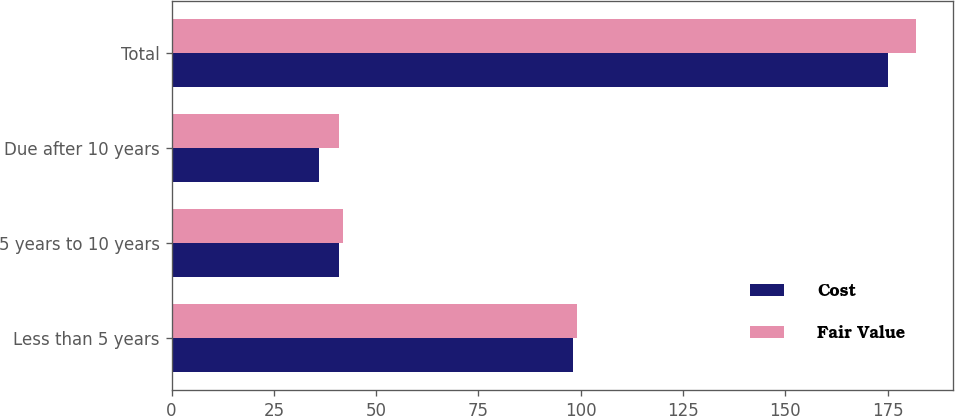Convert chart to OTSL. <chart><loc_0><loc_0><loc_500><loc_500><stacked_bar_chart><ecel><fcel>Less than 5 years<fcel>5 years to 10 years<fcel>Due after 10 years<fcel>Total<nl><fcel>Cost<fcel>98<fcel>41<fcel>36<fcel>175<nl><fcel>Fair Value<fcel>99<fcel>42<fcel>41<fcel>182<nl></chart> 